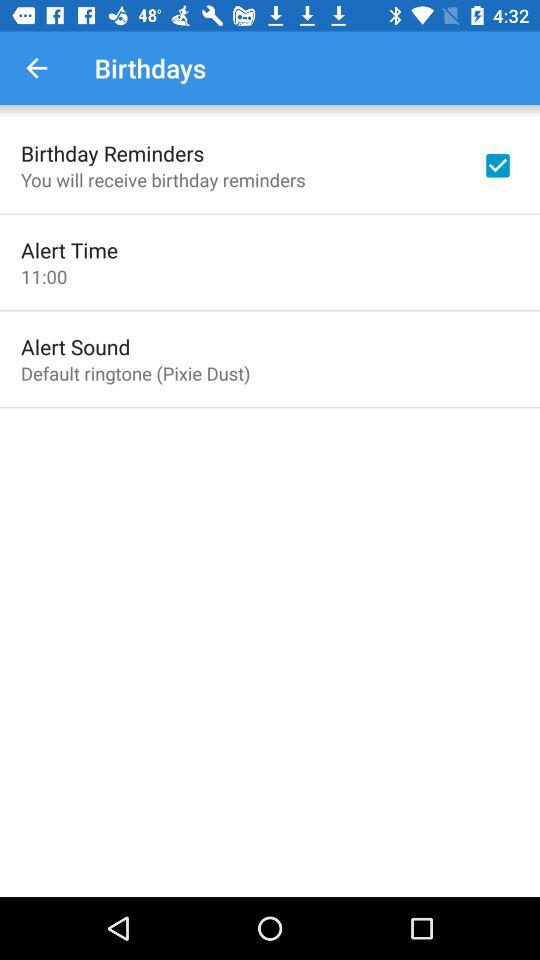What is the time of the alert? The time of the alert is 11:00. 